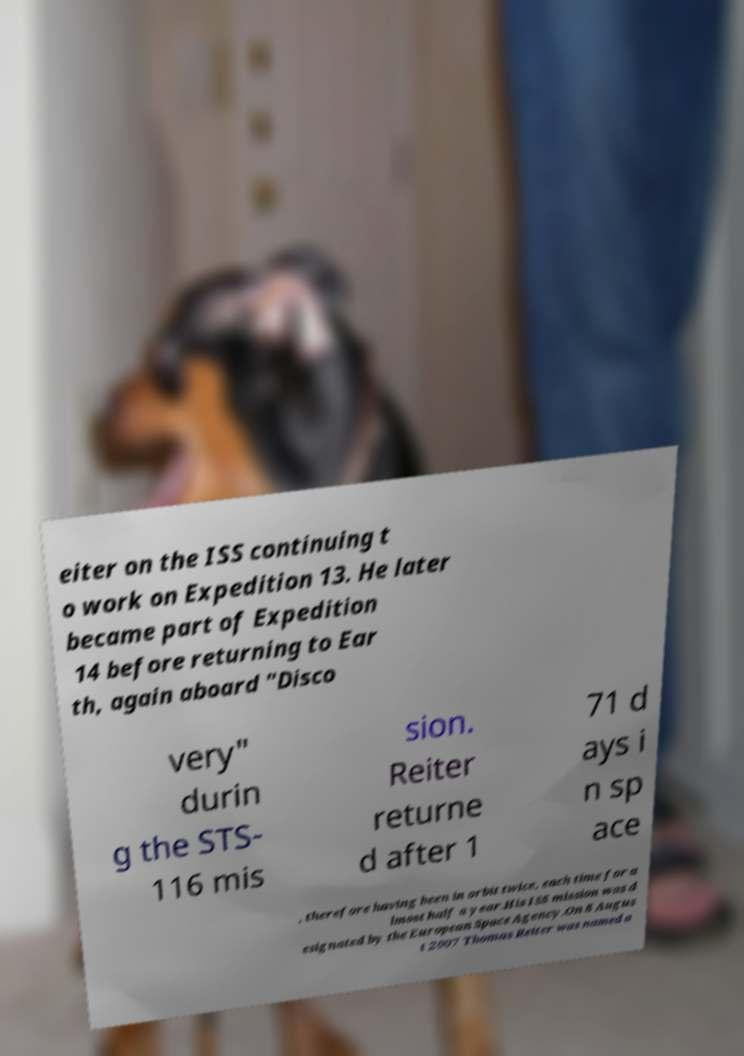There's text embedded in this image that I need extracted. Can you transcribe it verbatim? eiter on the ISS continuing t o work on Expedition 13. He later became part of Expedition 14 before returning to Ear th, again aboard "Disco very" durin g the STS- 116 mis sion. Reiter returne d after 1 71 d ays i n sp ace , therefore having been in orbit twice, each time for a lmost half a year.His ISS mission was d esignated by the European Space Agency.On 8 Augus t 2007 Thomas Reiter was named a 